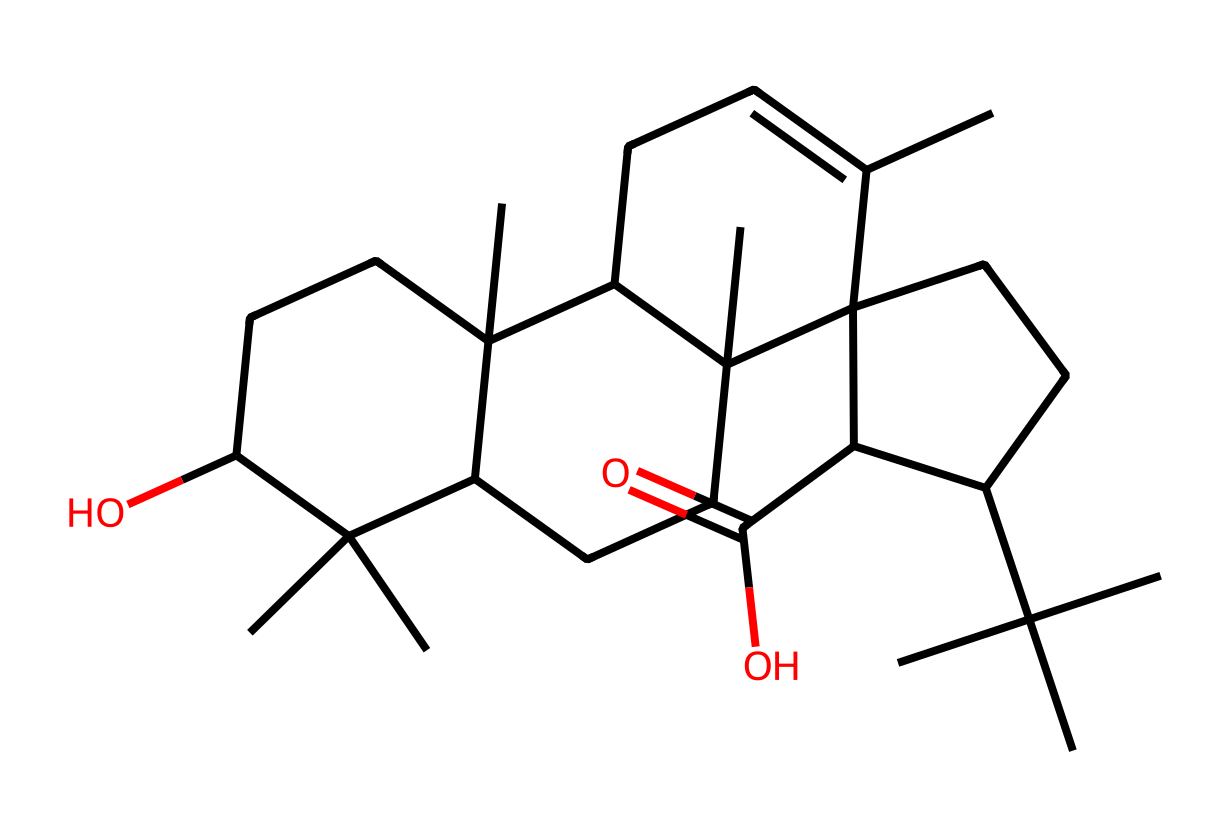how many carbon atoms are in boswellic acid? By analyzing the SMILES representation, we can count the number of carbon (C) symbols present in the structure. The SMILES includes multiple branching and cyclic structures, but a thorough count reveals there are 30 carbon atoms in total.
Answer: 30 what is the functional group present in boswellic acid? The presence of the -COOH (carboxylic acid) functional group can be identified by looking for the carbon (C) connected to both carbon and hydroxyl (OH) group in the structure. This specific arrangement indicates the presence of a carboxylic acid functional group in boswellic acid.
Answer: carboxylic acid how many rings are present in boswellic acid? We can identify cyclic structures in the SMILES notation. By examining the structure, we note there are 4 rings present, which are specifically indicated by the numbers in the SMILES representing ring closures.
Answer: 4 what type of compound is boswellic acid classified as? The presence of multiple branches along with a carboxylic acid functional group indicates that boswellic acid is a triterpenoid, which is a type of organic compound known for its diverse applications and natural sources.
Answer: triterpenoid which structural feature contributes to boswellic acid's aroma? The cyclic structures and the specific arrangement of branches in the chemical structure create a complex molecular environment that contributes to its characteristic aroma, indicating it has terpenoid features that are significant in the fragrance profile.
Answer: terpenoid 